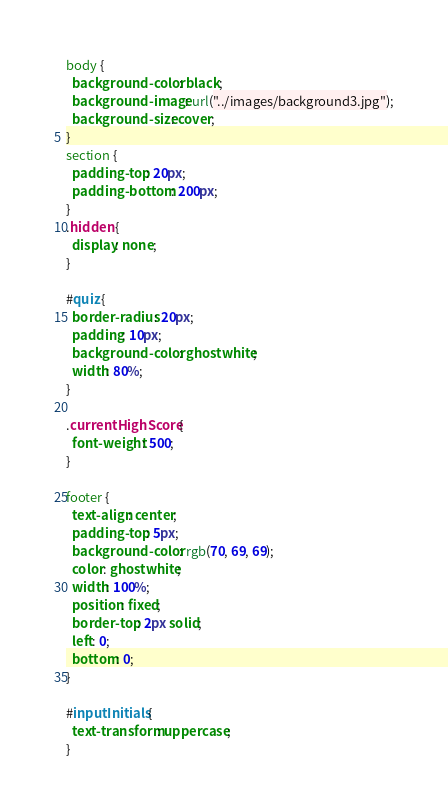Convert code to text. <code><loc_0><loc_0><loc_500><loc_500><_CSS_>body {
  background-color: black;
  background-image: url("../images/background3.jpg");
  background-size: cover;
}
section {
  padding-top: 20px;
  padding-bottom: 200px;
}
.hidden {
  display: none;
}

#quiz {
  border-radius: 20px;
  padding: 10px;
  background-color: ghostwhite;
  width: 80%;
}

.currentHighScore {
  font-weight: 500;
}

footer {
  text-align: center;
  padding-top: 5px;
  background-color: rgb(70, 69, 69);
  color: ghostwhite;
  width: 100%;
  position: fixed;
  border-top: 2px solid;
  left: 0;
  bottom: 0;
}

#inputInitials {
  text-transform: uppercase;
}</code> 